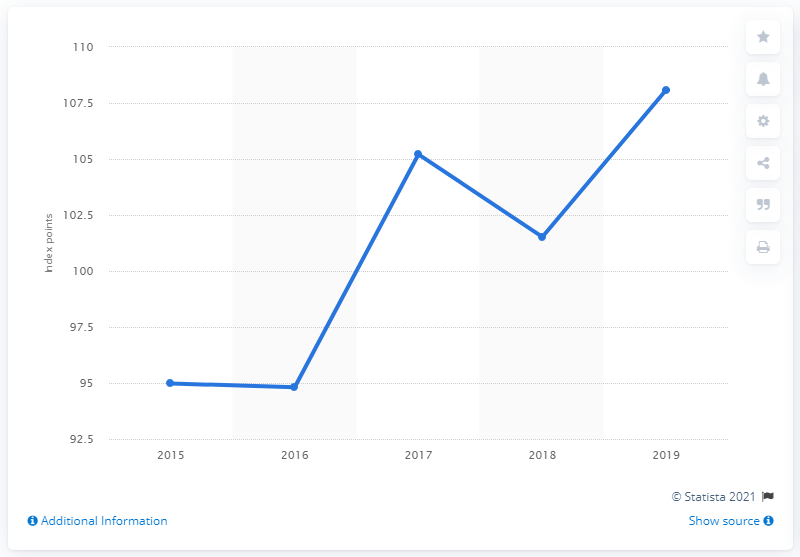Outline some significant characteristics in this image. As of the end of 2019, the Bloomberg Barclays MSCI Global Green Bond Index had reached a total of 108.08 index points. 